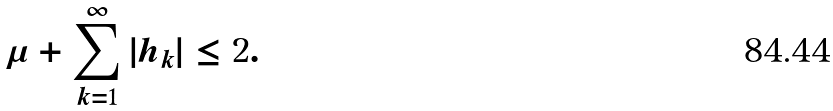Convert formula to latex. <formula><loc_0><loc_0><loc_500><loc_500>\mu + \sum _ { k = 1 } ^ { \infty } | h _ { k } | \leq 2 .</formula> 